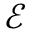Convert formula to latex. <formula><loc_0><loc_0><loc_500><loc_500>\ m a t h s c r { E }</formula> 